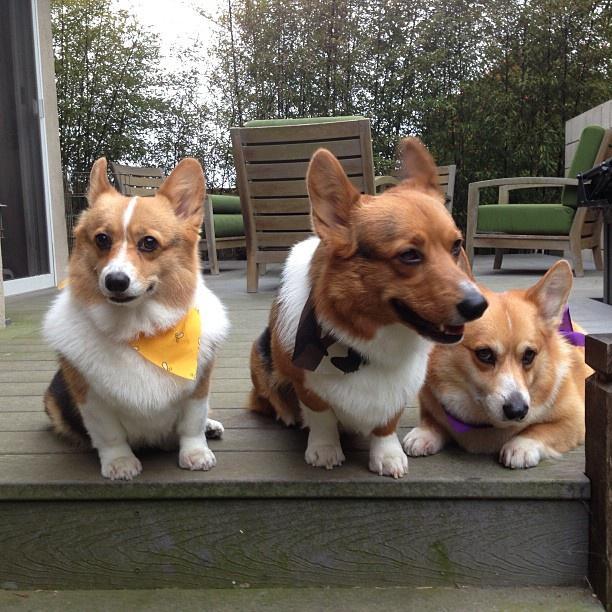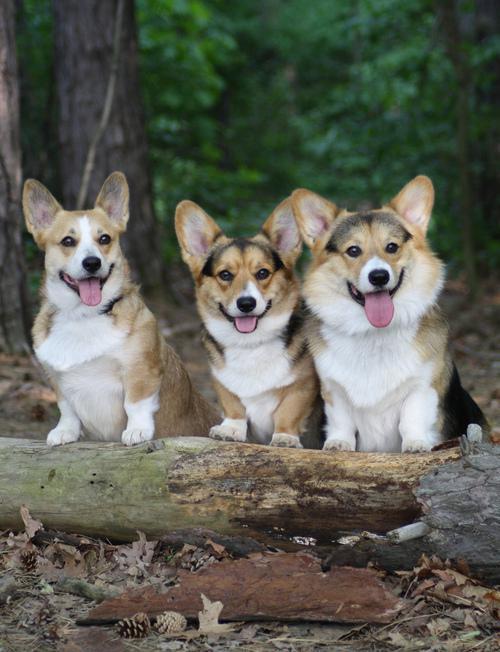The first image is the image on the left, the second image is the image on the right. Evaluate the accuracy of this statement regarding the images: "There are two small dogs wearing costumes". Is it true? Answer yes or no. No. The first image is the image on the left, the second image is the image on the right. Evaluate the accuracy of this statement regarding the images: "Corgis are dressing in costumes". Is it true? Answer yes or no. No. 